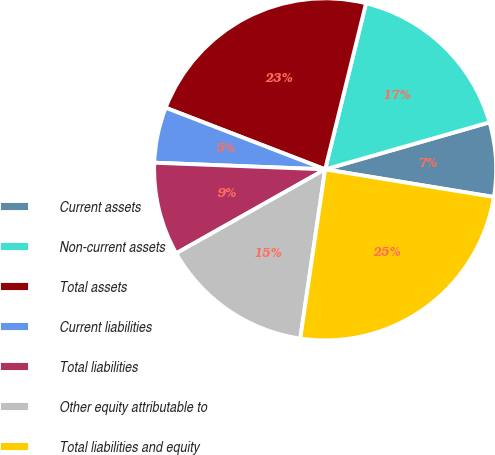Convert chart to OTSL. <chart><loc_0><loc_0><loc_500><loc_500><pie_chart><fcel>Current assets<fcel>Non-current assets<fcel>Total assets<fcel>Current liabilities<fcel>Total liabilities<fcel>Other equity attributable to<fcel>Total liabilities and equity<nl><fcel>7.02%<fcel>16.72%<fcel>22.97%<fcel>5.25%<fcel>8.79%<fcel>14.5%<fcel>24.74%<nl></chart> 